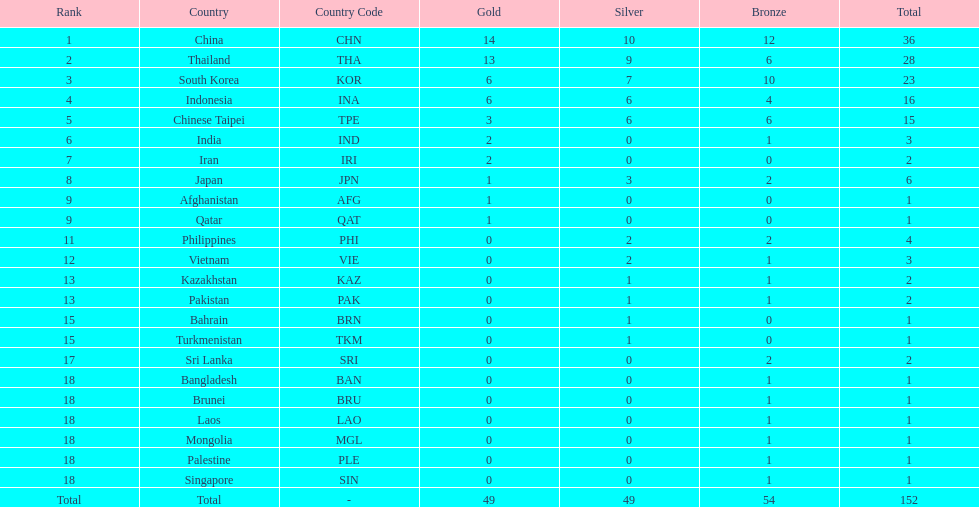What is the total number of nations that participated in the beach games of 2012? 23. 